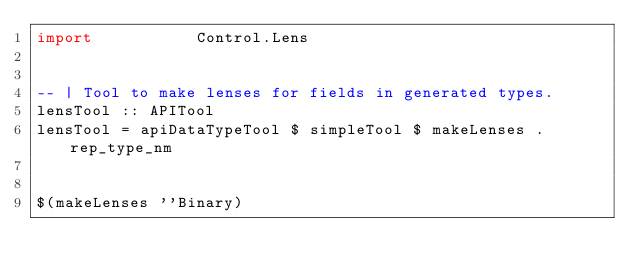Convert code to text. <code><loc_0><loc_0><loc_500><loc_500><_Haskell_>import           Control.Lens


-- | Tool to make lenses for fields in generated types.
lensTool :: APITool
lensTool = apiDataTypeTool $ simpleTool $ makeLenses . rep_type_nm


$(makeLenses ''Binary)
</code> 